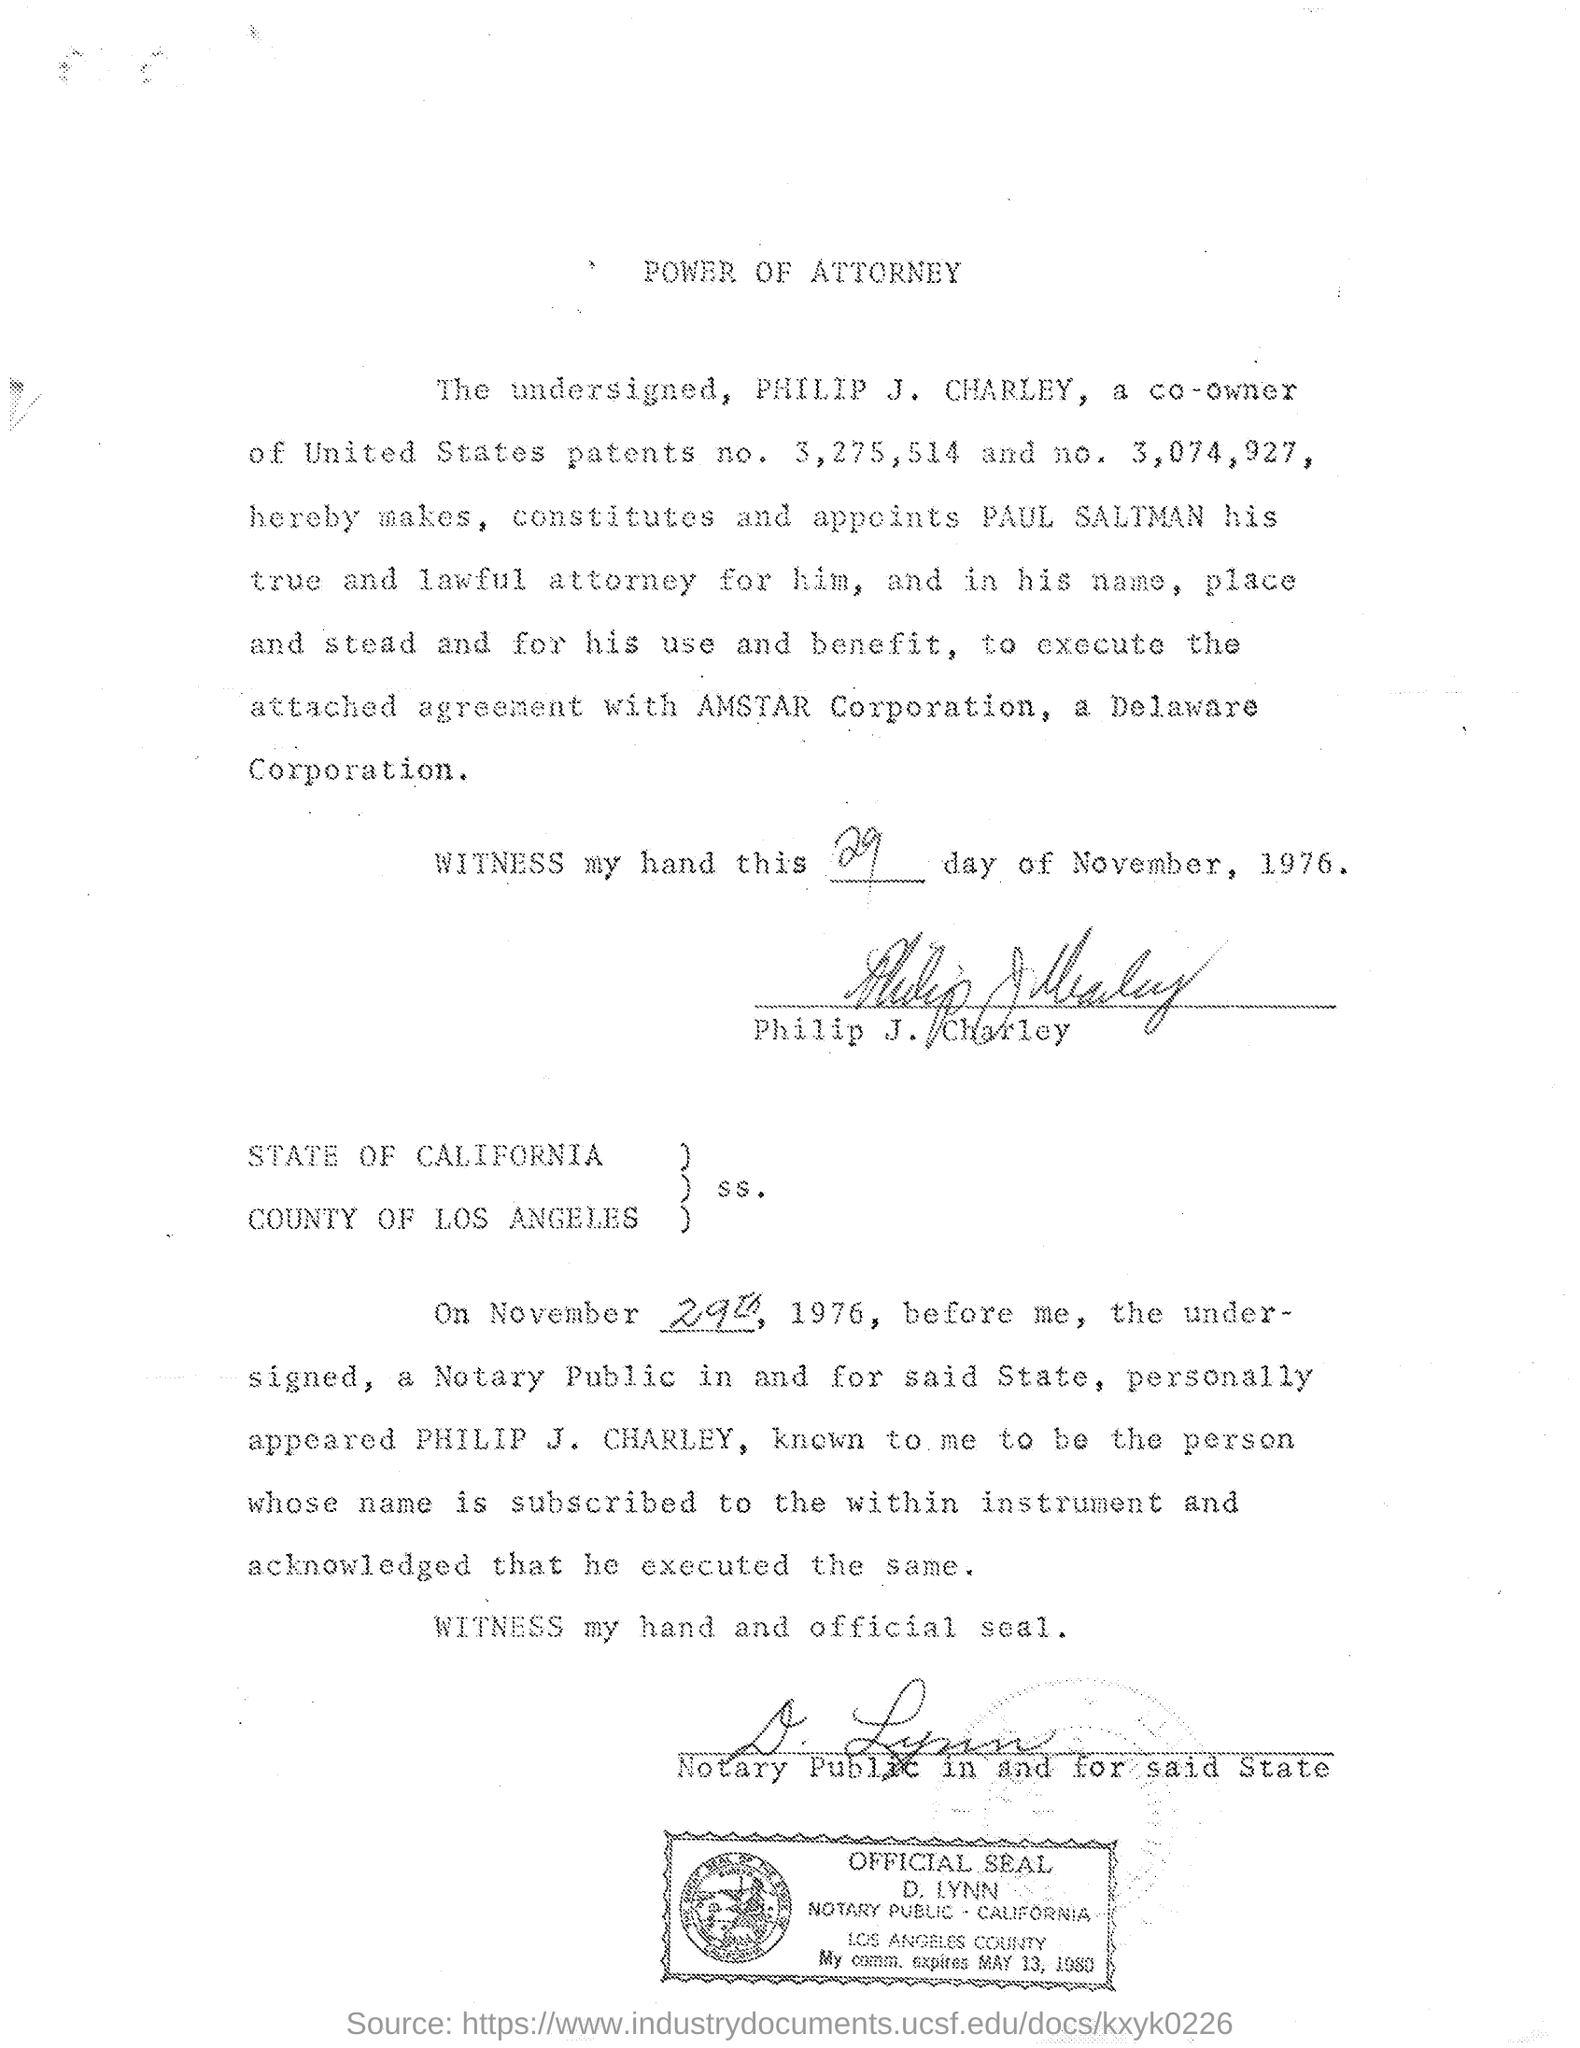Specify some key components in this picture. The power of attorney was made in the name of Paul Saltman. 